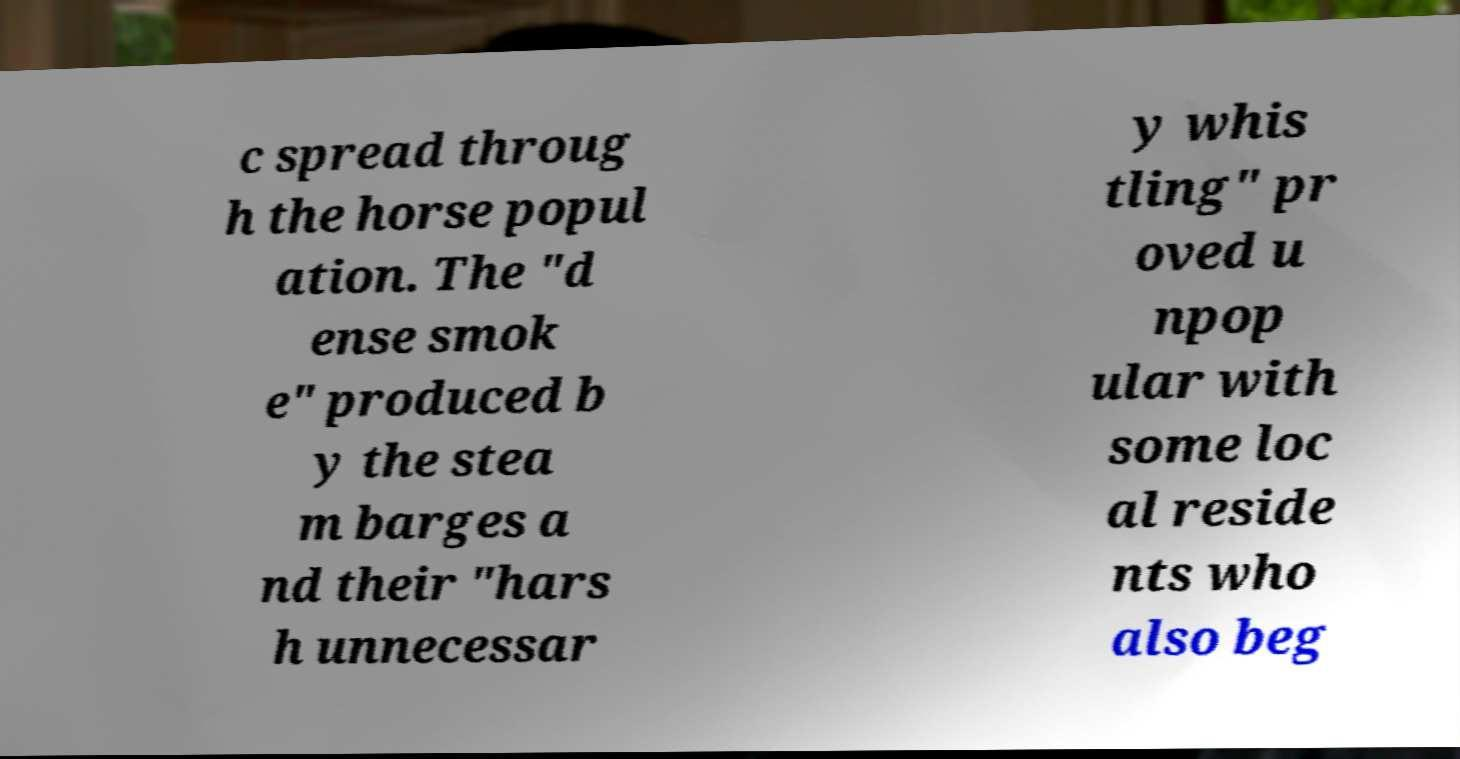There's text embedded in this image that I need extracted. Can you transcribe it verbatim? c spread throug h the horse popul ation. The "d ense smok e" produced b y the stea m barges a nd their "hars h unnecessar y whis tling" pr oved u npop ular with some loc al reside nts who also beg 